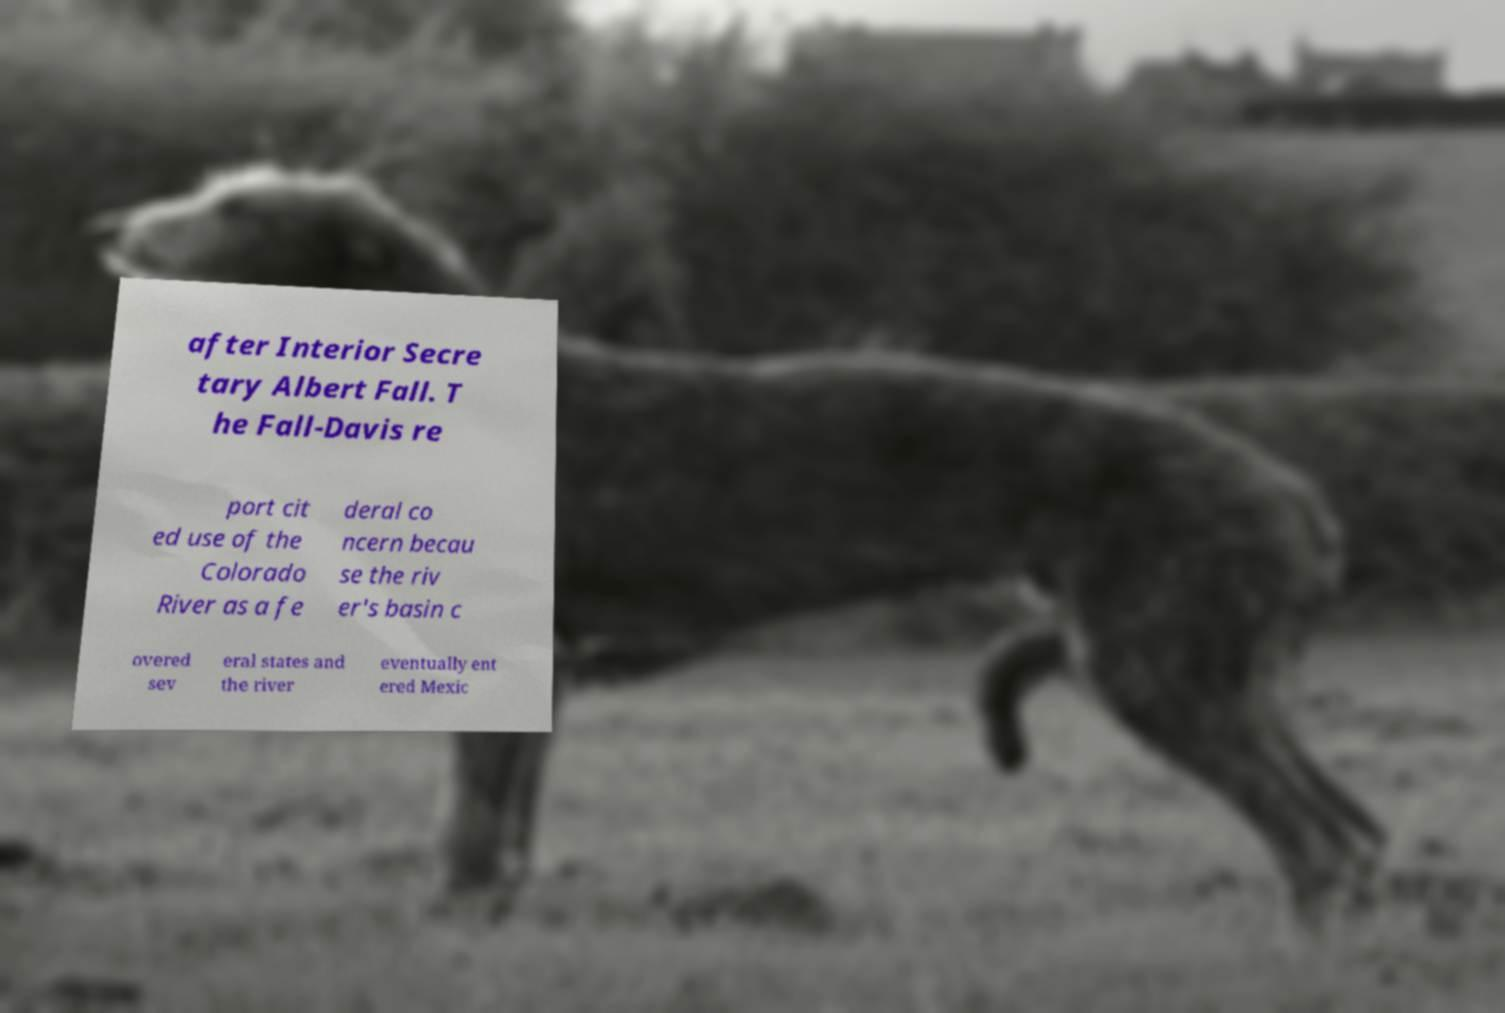Please identify and transcribe the text found in this image. after Interior Secre tary Albert Fall. T he Fall-Davis re port cit ed use of the Colorado River as a fe deral co ncern becau se the riv er's basin c overed sev eral states and the river eventually ent ered Mexic 